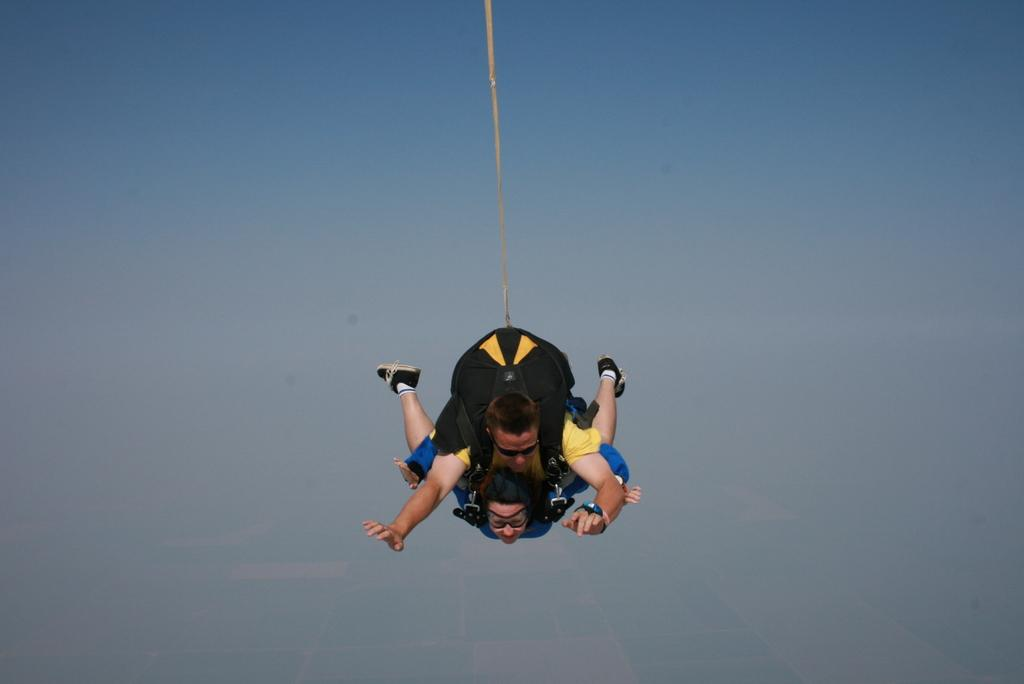How many people are in the image? There are two people in the image, a man and a woman. What are the man and woman doing in the image? The man and woman are in the air. What is in the middle of the image? There is a rope in the middle of the image. What can be seen in the background of the image? There is a sky visible in the background of the image. What type of chicken can be seen enjoying the summer holiday in the image? There is no chicken or reference to a summer holiday present in the image. 